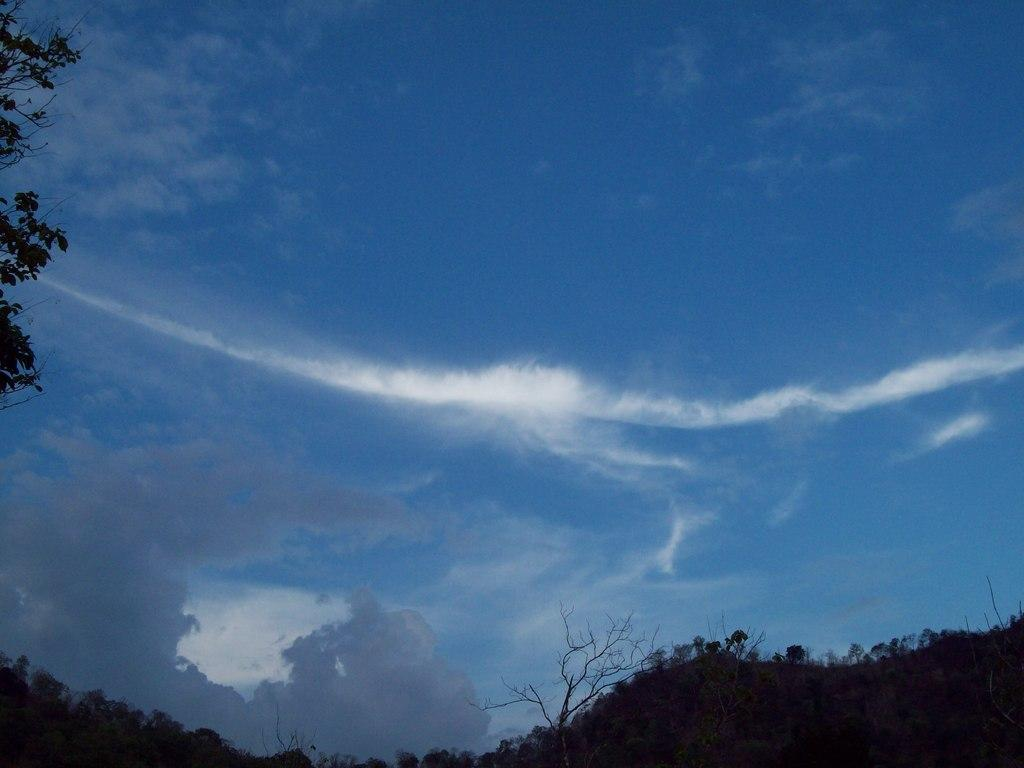Where was the image taken? The image was taken outdoors. What can be seen in the sky in the image? There is a sky with clouds visible in the image. What type of natural elements are present at the bottom of the image? There are many trees and plants at the bottom of the image. Who is the grandfather in the image? There is no grandfather present in the image. What type of wound can be seen on the trees in the image? There are no wounds visible on the trees in the image. 